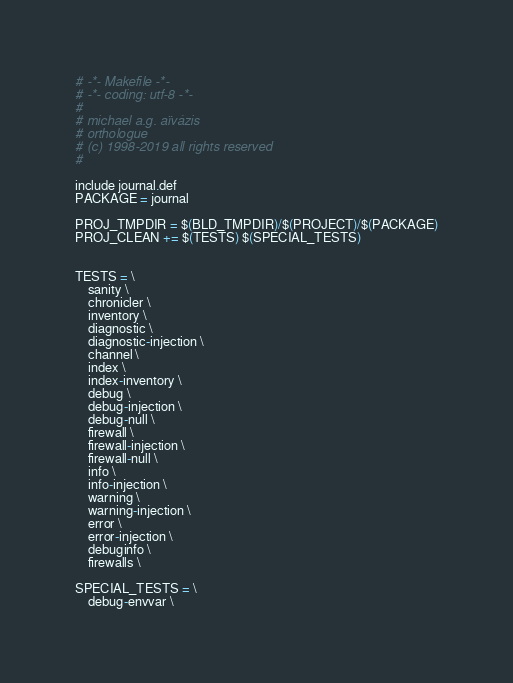Convert code to text. <code><loc_0><loc_0><loc_500><loc_500><_ObjectiveC_># -*- Makefile -*-
# -*- coding: utf-8 -*-
#
# michael a.g. aïvázis
# orthologue
# (c) 1998-2019 all rights reserved
#

include journal.def
PACKAGE = journal

PROJ_TMPDIR = $(BLD_TMPDIR)/$(PROJECT)/$(PACKAGE)
PROJ_CLEAN += $(TESTS) $(SPECIAL_TESTS)


TESTS = \
    sanity \
    chronicler \
    inventory \
    diagnostic \
    diagnostic-injection \
    channel \
    index \
    index-inventory \
    debug \
    debug-injection \
    debug-null \
    firewall \
    firewall-injection \
    firewall-null \
    info \
    info-injection \
    warning \
    warning-injection \
    error \
    error-injection \
    debuginfo \
    firewalls \

SPECIAL_TESTS = \
    debug-envvar \
</code> 